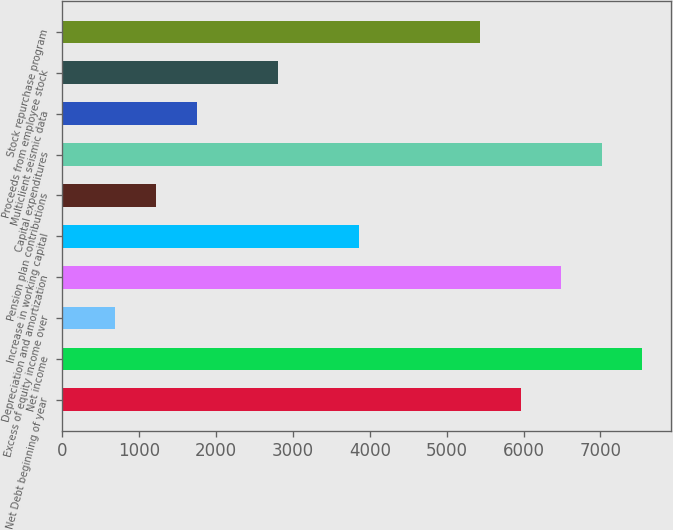Convert chart. <chart><loc_0><loc_0><loc_500><loc_500><bar_chart><fcel>Net Debt beginning of year<fcel>Net income<fcel>Excess of equity income over<fcel>Depreciation and amortization<fcel>Increase in working capital<fcel>Pension plan contributions<fcel>Capital expenditures<fcel>Multiclient seismic data<fcel>Proceeds from employee stock<fcel>Stock repurchase program<nl><fcel>5961.9<fcel>7542.6<fcel>692.9<fcel>6488.8<fcel>3854.3<fcel>1219.8<fcel>7015.7<fcel>1746.7<fcel>2800.5<fcel>5435<nl></chart> 